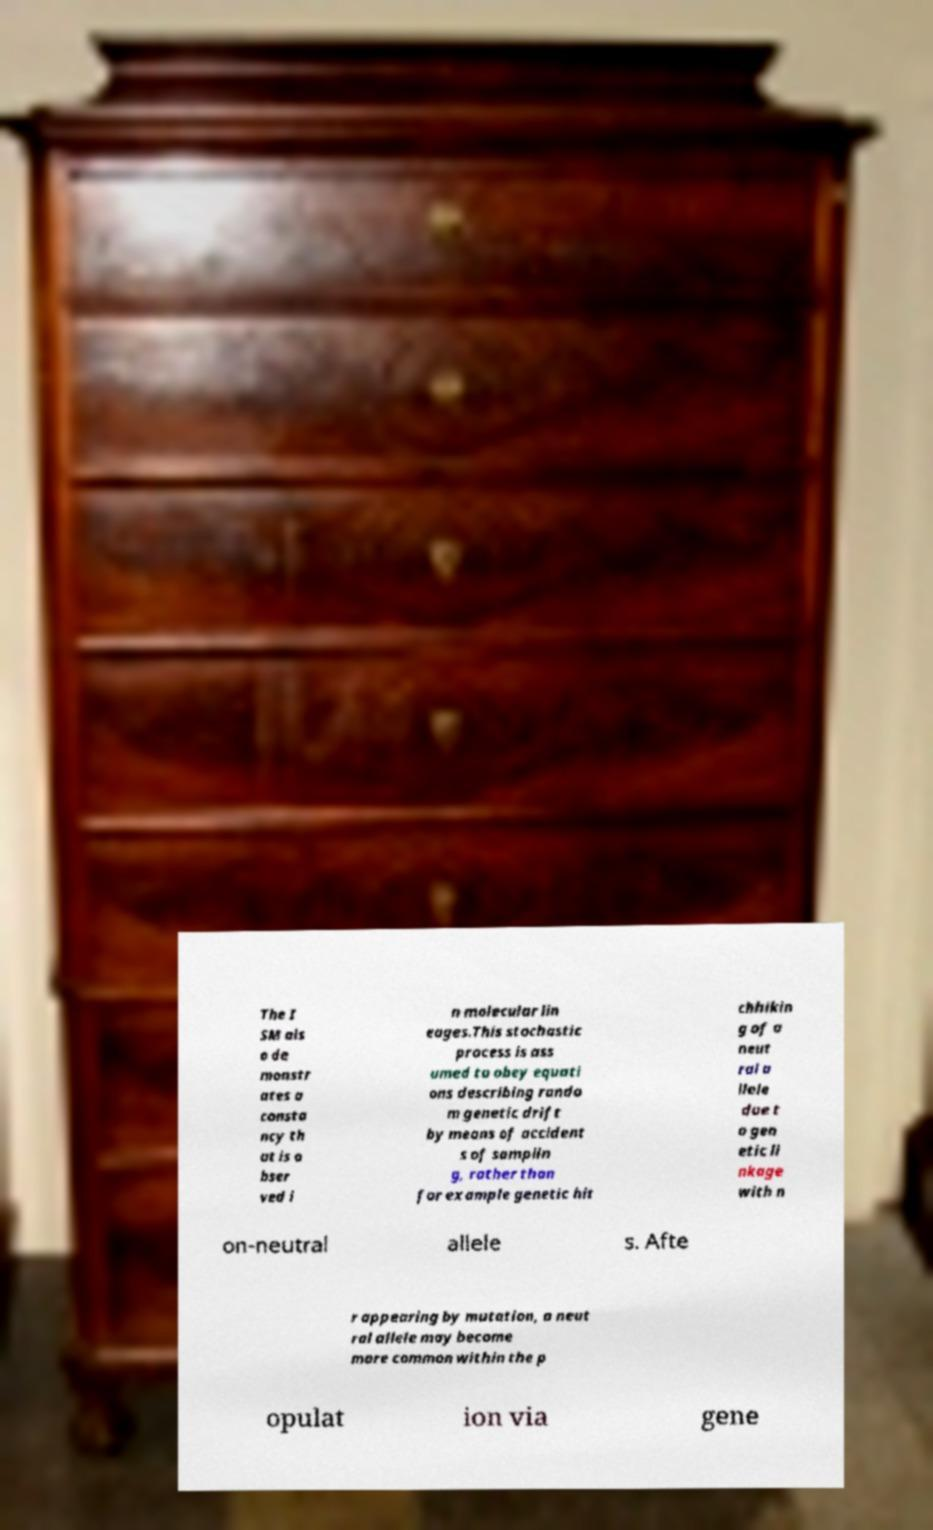Could you extract and type out the text from this image? The I SM als o de monstr ates a consta ncy th at is o bser ved i n molecular lin eages.This stochastic process is ass umed to obey equati ons describing rando m genetic drift by means of accident s of samplin g, rather than for example genetic hit chhikin g of a neut ral a llele due t o gen etic li nkage with n on-neutral allele s. Afte r appearing by mutation, a neut ral allele may become more common within the p opulat ion via gene 